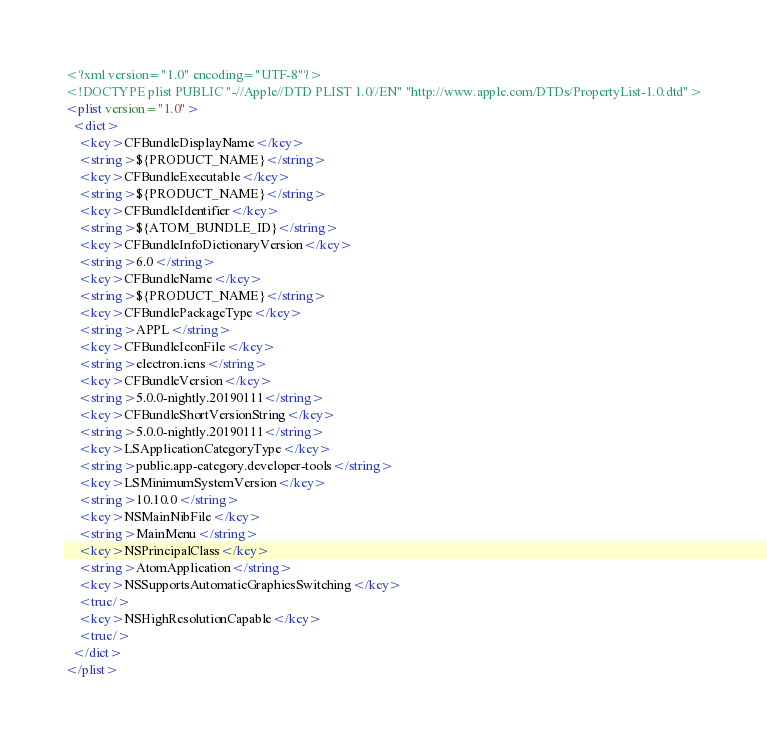<code> <loc_0><loc_0><loc_500><loc_500><_XML_><?xml version="1.0" encoding="UTF-8"?>
<!DOCTYPE plist PUBLIC "-//Apple//DTD PLIST 1.0//EN" "http://www.apple.com/DTDs/PropertyList-1.0.dtd">
<plist version="1.0">
  <dict>
    <key>CFBundleDisplayName</key>
    <string>${PRODUCT_NAME}</string>
    <key>CFBundleExecutable</key>
    <string>${PRODUCT_NAME}</string>
    <key>CFBundleIdentifier</key>
    <string>${ATOM_BUNDLE_ID}</string>
    <key>CFBundleInfoDictionaryVersion</key>
    <string>6.0</string>
    <key>CFBundleName</key>
    <string>${PRODUCT_NAME}</string>
    <key>CFBundlePackageType</key>
    <string>APPL</string>
    <key>CFBundleIconFile</key>
    <string>electron.icns</string>
    <key>CFBundleVersion</key>
    <string>5.0.0-nightly.20190111</string>
    <key>CFBundleShortVersionString</key>
    <string>5.0.0-nightly.20190111</string>
    <key>LSApplicationCategoryType</key>
    <string>public.app-category.developer-tools</string>
    <key>LSMinimumSystemVersion</key>
    <string>10.10.0</string>
    <key>NSMainNibFile</key>
    <string>MainMenu</string>
    <key>NSPrincipalClass</key>
    <string>AtomApplication</string>
    <key>NSSupportsAutomaticGraphicsSwitching</key>
    <true/>
    <key>NSHighResolutionCapable</key>
    <true/>
  </dict>
</plist></code> 